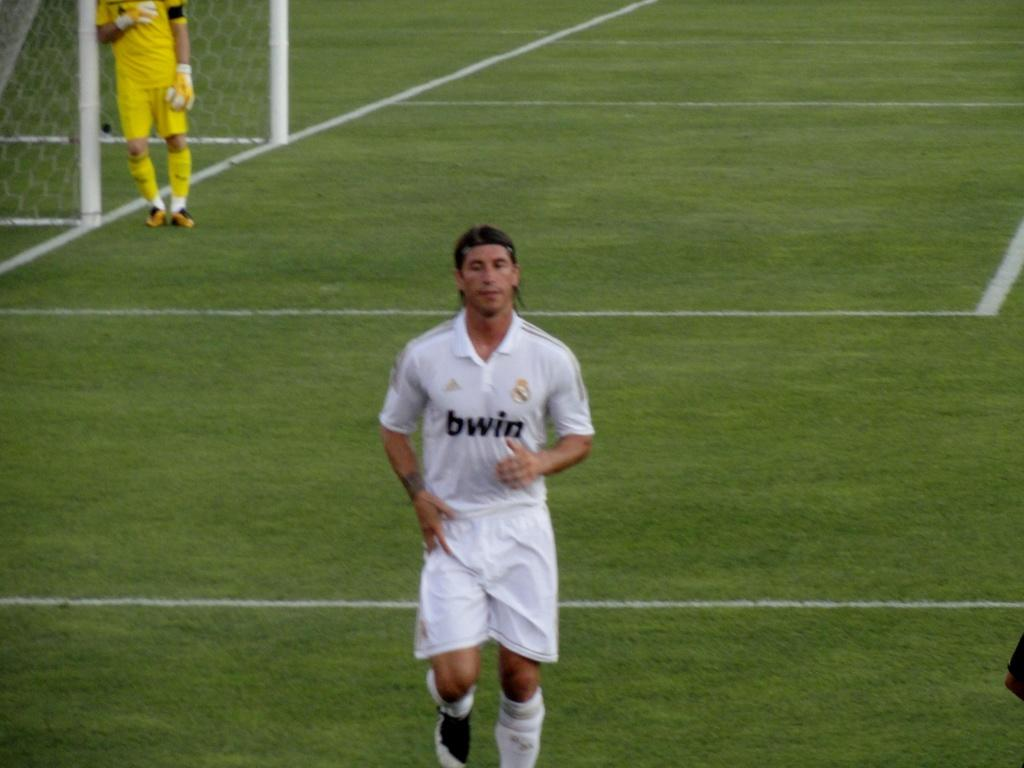What is the football player doing in the image? The football player is running in the image. Where is the football player located in relation to the ground? The football player is on the ground. What can be seen in the background of the image? There is a goal post in the background of the image. Who is present near the goal post? There is a goalkeeper beside the goal post. What type of surface is the football player running on? The ground has grass on it. What type of alarm can be seen in the image? There is no alarm present in the image. 